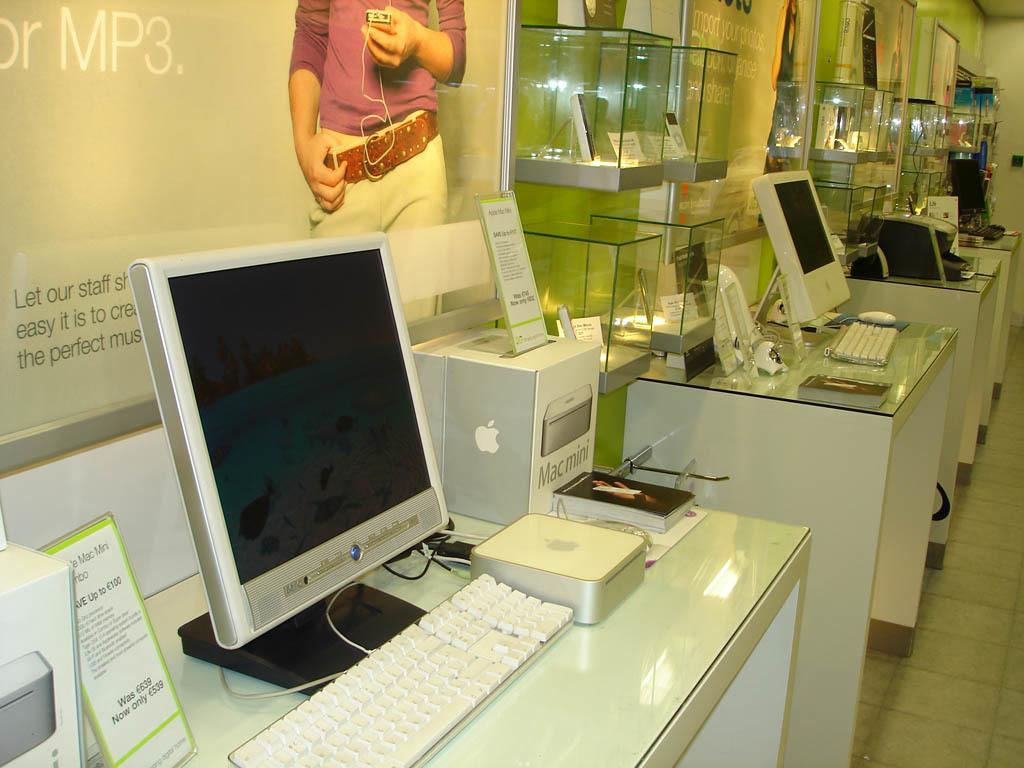<image>
Offer a succinct explanation of the picture presented. An Apple store with a variety of products including a Mac mini 